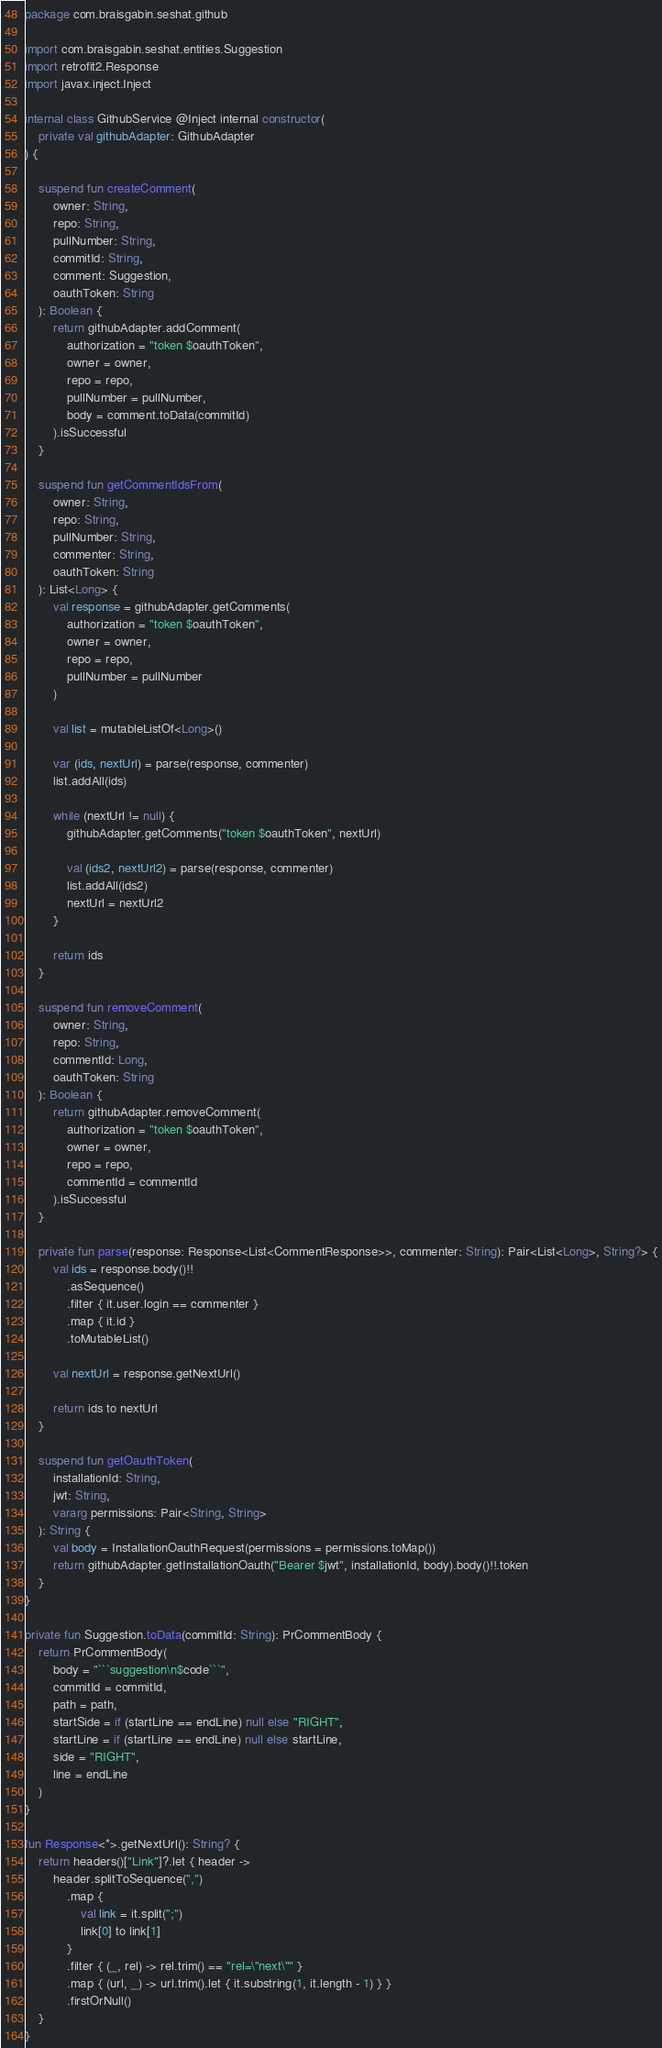Convert code to text. <code><loc_0><loc_0><loc_500><loc_500><_Kotlin_>package com.braisgabin.seshat.github

import com.braisgabin.seshat.entities.Suggestion
import retrofit2.Response
import javax.inject.Inject

internal class GithubService @Inject internal constructor(
    private val githubAdapter: GithubAdapter
) {

    suspend fun createComment(
        owner: String,
        repo: String,
        pullNumber: String,
        commitId: String,
        comment: Suggestion,
        oauthToken: String
    ): Boolean {
        return githubAdapter.addComment(
            authorization = "token $oauthToken",
            owner = owner,
            repo = repo,
            pullNumber = pullNumber,
            body = comment.toData(commitId)
        ).isSuccessful
    }

    suspend fun getCommentIdsFrom(
        owner: String,
        repo: String,
        pullNumber: String,
        commenter: String,
        oauthToken: String
    ): List<Long> {
        val response = githubAdapter.getComments(
            authorization = "token $oauthToken",
            owner = owner,
            repo = repo,
            pullNumber = pullNumber
        )

        val list = mutableListOf<Long>()

        var (ids, nextUrl) = parse(response, commenter)
        list.addAll(ids)

        while (nextUrl != null) {
            githubAdapter.getComments("token $oauthToken", nextUrl)

            val (ids2, nextUrl2) = parse(response, commenter)
            list.addAll(ids2)
            nextUrl = nextUrl2
        }

        return ids
    }

    suspend fun removeComment(
        owner: String,
        repo: String,
        commentId: Long,
        oauthToken: String
    ): Boolean {
        return githubAdapter.removeComment(
            authorization = "token $oauthToken",
            owner = owner,
            repo = repo,
            commentId = commentId
        ).isSuccessful
    }

    private fun parse(response: Response<List<CommentResponse>>, commenter: String): Pair<List<Long>, String?> {
        val ids = response.body()!!
            .asSequence()
            .filter { it.user.login == commenter }
            .map { it.id }
            .toMutableList()

        val nextUrl = response.getNextUrl()

        return ids to nextUrl
    }

    suspend fun getOauthToken(
        installationId: String,
        jwt: String,
        vararg permissions: Pair<String, String>
    ): String {
        val body = InstallationOauthRequest(permissions = permissions.toMap())
        return githubAdapter.getInstallationOauth("Bearer $jwt", installationId, body).body()!!.token
    }
}

private fun Suggestion.toData(commitId: String): PrCommentBody {
    return PrCommentBody(
        body = "```suggestion\n$code```",
        commitId = commitId,
        path = path,
        startSide = if (startLine == endLine) null else "RIGHT",
        startLine = if (startLine == endLine) null else startLine,
        side = "RIGHT",
        line = endLine
    )
}

fun Response<*>.getNextUrl(): String? {
    return headers()["Link"]?.let { header ->
        header.splitToSequence(",")
            .map {
                val link = it.split(";")
                link[0] to link[1]
            }
            .filter { (_, rel) -> rel.trim() == "rel=\"next\"" }
            .map { (url, _) -> url.trim().let { it.substring(1, it.length - 1) } }
            .firstOrNull()
    }
}
</code> 